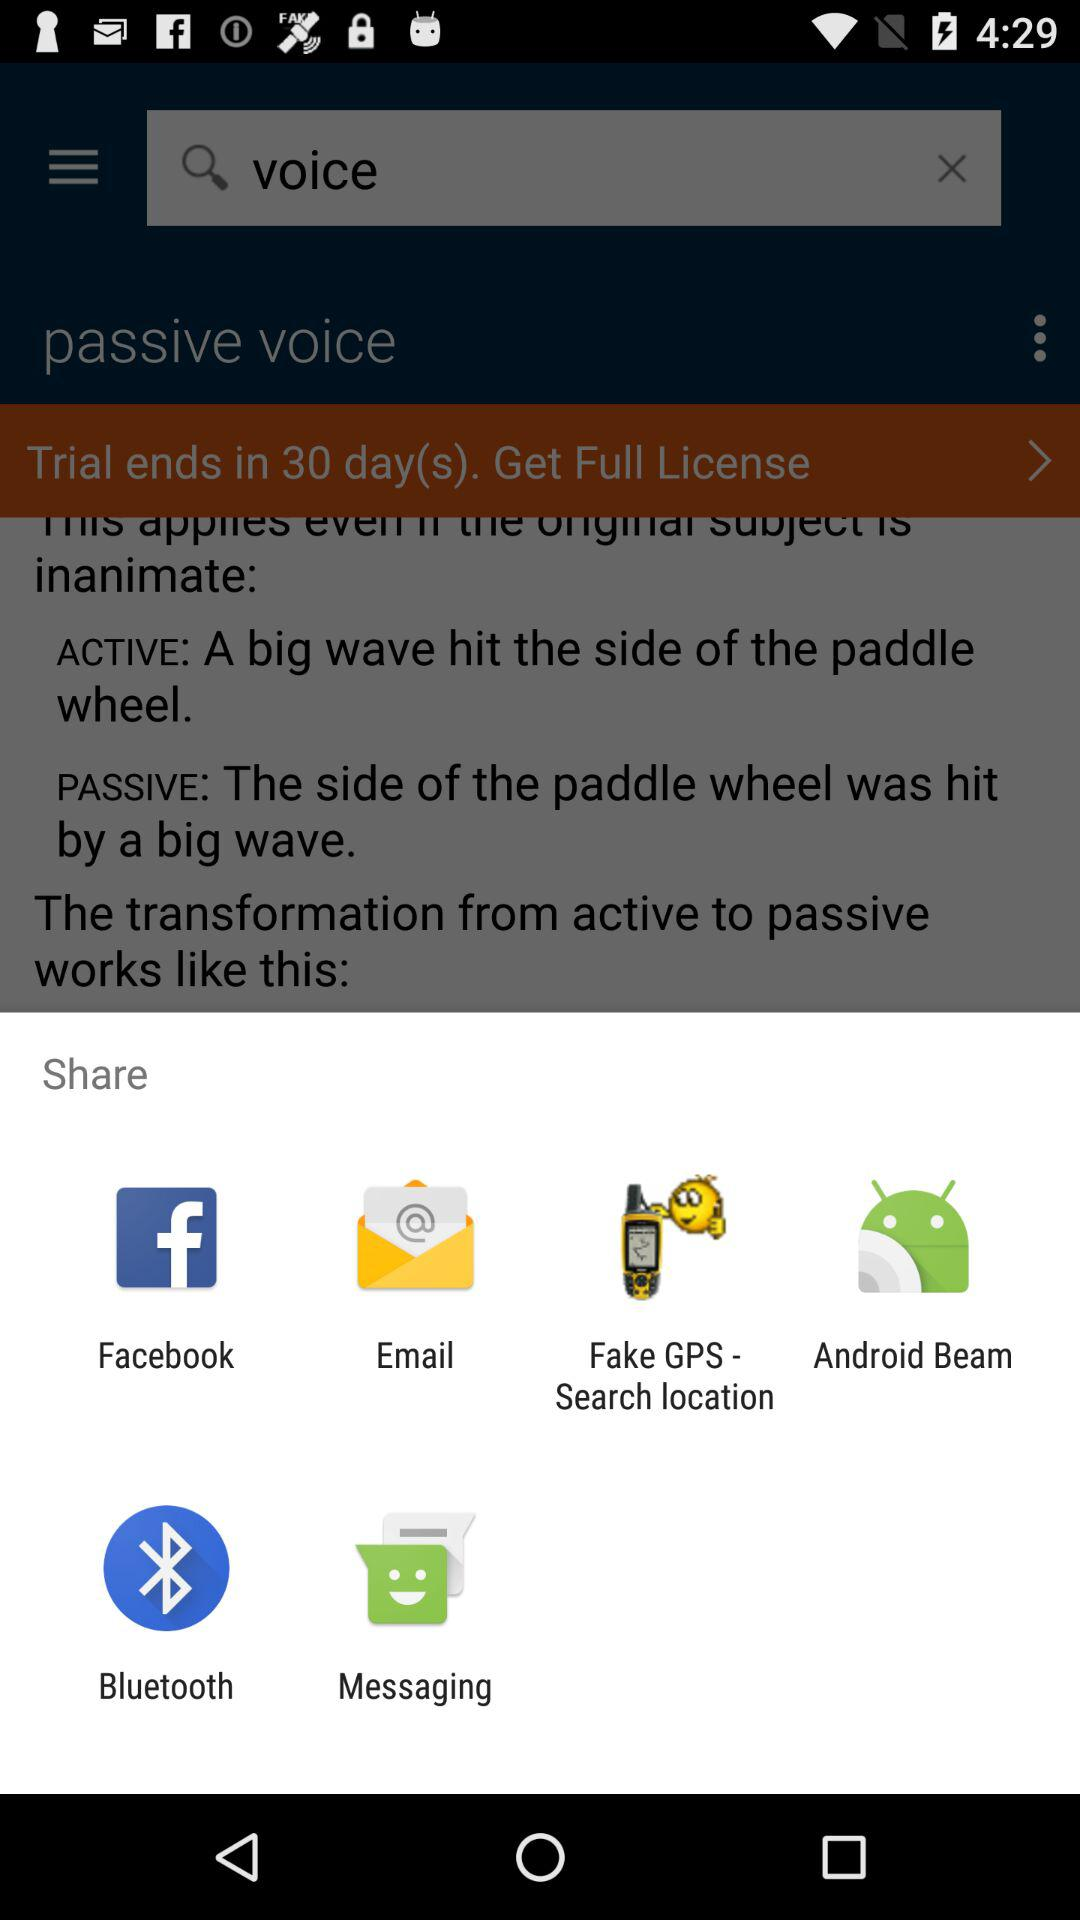What options are given for sharing? The options are "Facebook", "Email", "Fake GPS - Search location", "Android Beam", "Bluetooth" and "Messaging". 